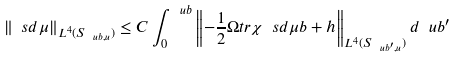<formula> <loc_0><loc_0><loc_500><loc_500>\| \ s d \mu \| _ { L ^ { 4 } ( S _ { \ u b , u } ) } \leq C \int _ { 0 } ^ { \ u b } \left \| - \frac { 1 } { 2 } \Omega t r \chi \ s d \mu b + h \right \| _ { L ^ { 4 } ( S _ { \ u b ^ { \prime } , u } ) } d \ u b ^ { \prime }</formula> 